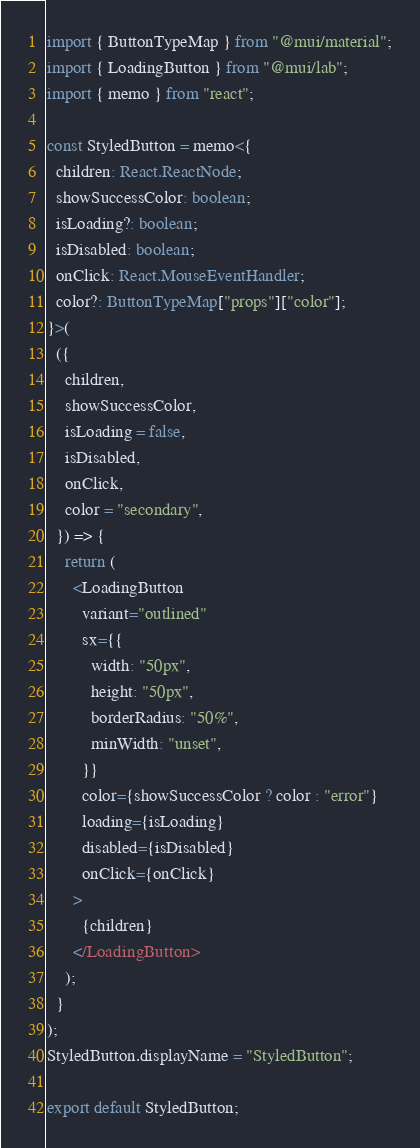Convert code to text. <code><loc_0><loc_0><loc_500><loc_500><_TypeScript_>import { ButtonTypeMap } from "@mui/material";
import { LoadingButton } from "@mui/lab";
import { memo } from "react";

const StyledButton = memo<{
  children: React.ReactNode;
  showSuccessColor: boolean;
  isLoading?: boolean;
  isDisabled: boolean;
  onClick: React.MouseEventHandler;
  color?: ButtonTypeMap["props"]["color"];
}>(
  ({
    children,
    showSuccessColor,
    isLoading = false,
    isDisabled,
    onClick,
    color = "secondary",
  }) => {
    return (
      <LoadingButton
        variant="outlined"
        sx={{
          width: "50px",
          height: "50px",
          borderRadius: "50%",
          minWidth: "unset",
        }}
        color={showSuccessColor ? color : "error"}
        loading={isLoading}
        disabled={isDisabled}
        onClick={onClick}
      >
        {children}
      </LoadingButton>
    );
  }
);
StyledButton.displayName = "StyledButton";

export default StyledButton;
</code> 